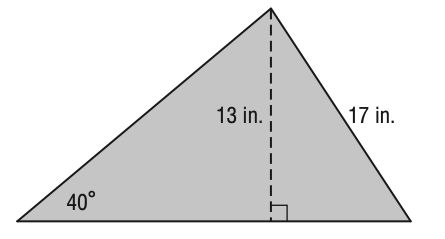Answer the mathemtical geometry problem and directly provide the correct option letter.
Question: What is the area of the triangle below? Round your answer to the nearest tenth if necessary.
Choices: A: 110.5 B: 144.2 C: 164.5 D: 171.9 D 